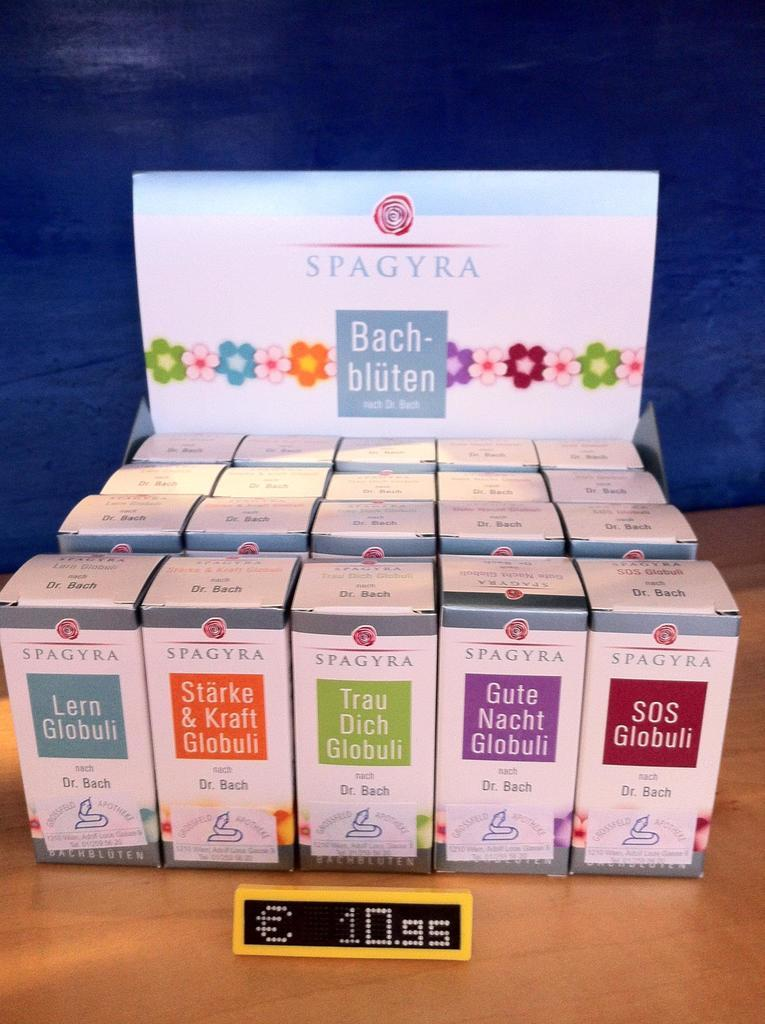<image>
Describe the image concisely. A product display for Spagyra Bach-bluten for 10.95 euros. 